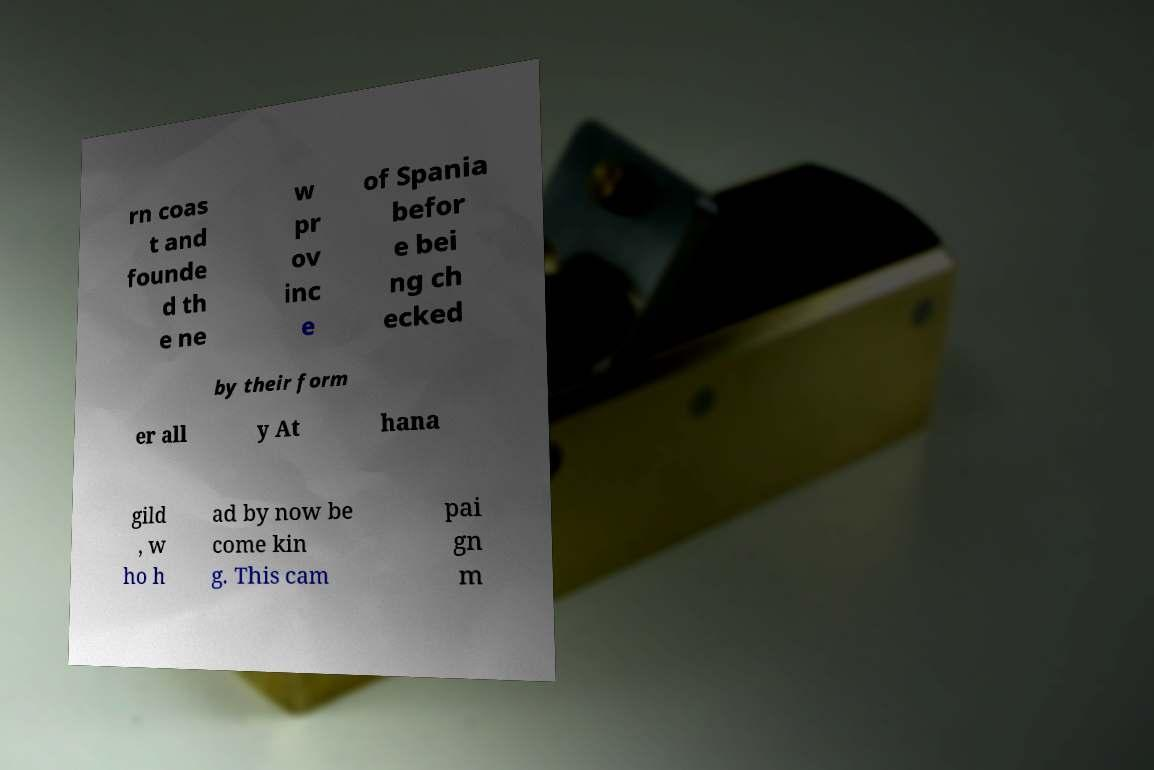What messages or text are displayed in this image? I need them in a readable, typed format. rn coas t and founde d th e ne w pr ov inc e of Spania befor e bei ng ch ecked by their form er all y At hana gild , w ho h ad by now be come kin g. This cam pai gn m 